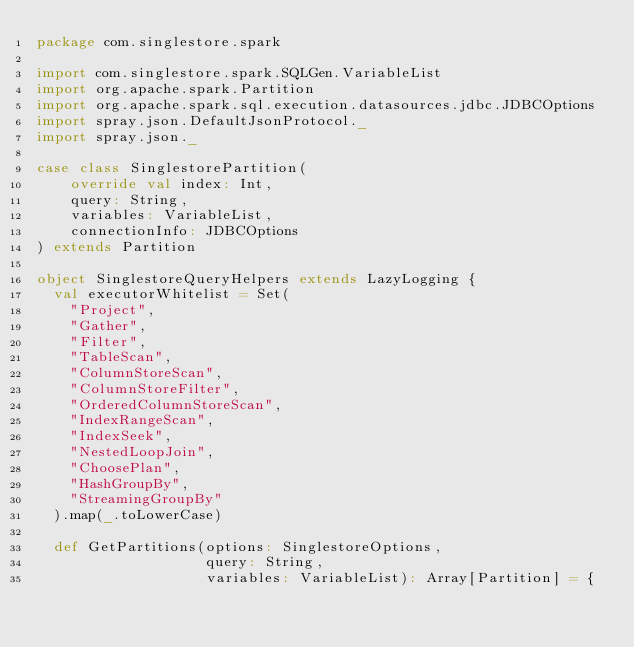<code> <loc_0><loc_0><loc_500><loc_500><_Scala_>package com.singlestore.spark

import com.singlestore.spark.SQLGen.VariableList
import org.apache.spark.Partition
import org.apache.spark.sql.execution.datasources.jdbc.JDBCOptions
import spray.json.DefaultJsonProtocol._
import spray.json._

case class SinglestorePartition(
    override val index: Int,
    query: String,
    variables: VariableList,
    connectionInfo: JDBCOptions
) extends Partition

object SinglestoreQueryHelpers extends LazyLogging {
  val executorWhitelist = Set(
    "Project",
    "Gather",
    "Filter",
    "TableScan",
    "ColumnStoreScan",
    "ColumnStoreFilter",
    "OrderedColumnStoreScan",
    "IndexRangeScan",
    "IndexSeek",
    "NestedLoopJoin",
    "ChoosePlan",
    "HashGroupBy",
    "StreamingGroupBy"
  ).map(_.toLowerCase)

  def GetPartitions(options: SinglestoreOptions,
                    query: String,
                    variables: VariableList): Array[Partition] = {
</code> 